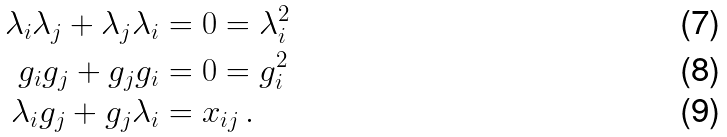<formula> <loc_0><loc_0><loc_500><loc_500>\lambda _ { i } \lambda _ { j } + \lambda _ { j } \lambda _ { i } & = 0 = \lambda _ { i } ^ { 2 } \\ g _ { i } g _ { j } + g _ { j } g _ { i } & = 0 = g _ { i } ^ { 2 } \\ \lambda _ { i } g _ { j } + g _ { j } \lambda _ { i } & = x _ { i j } \, .</formula> 